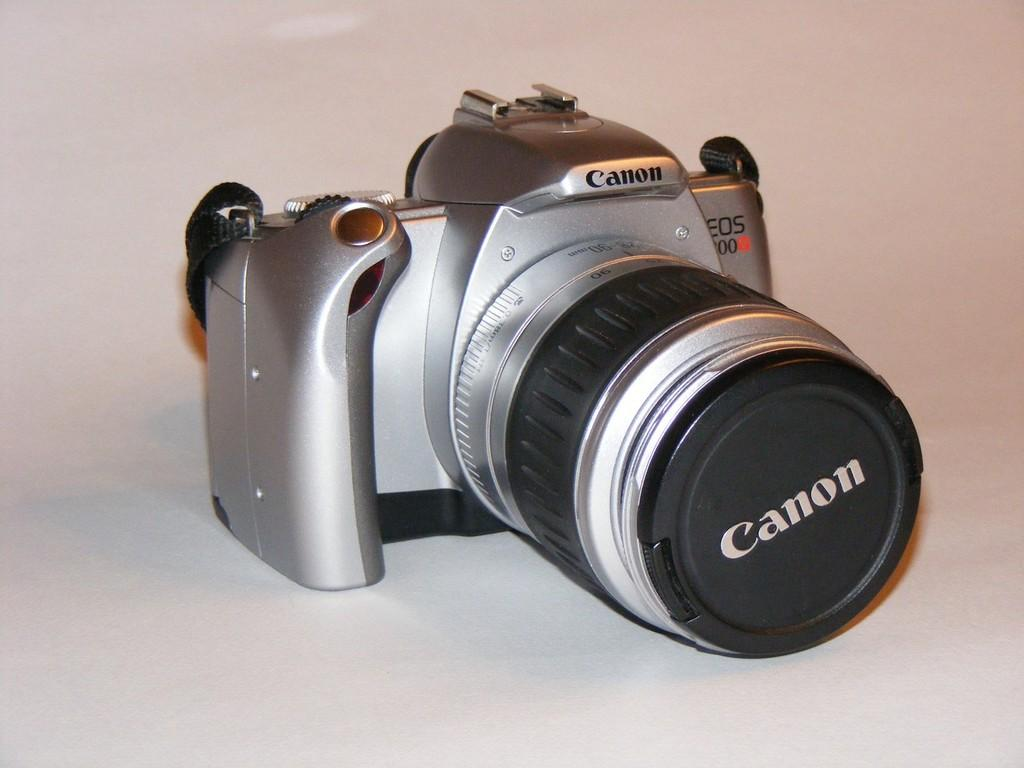What type of camera is visible in the image? There is a Canon camera in the image. What is the color of the surface on which the camera is placed? The camera is placed on a white surface. What type of yarn is being used to create a pattern on the camera in the image? There is no yarn present in the image, and the camera does not have any patterns created by yarn. 